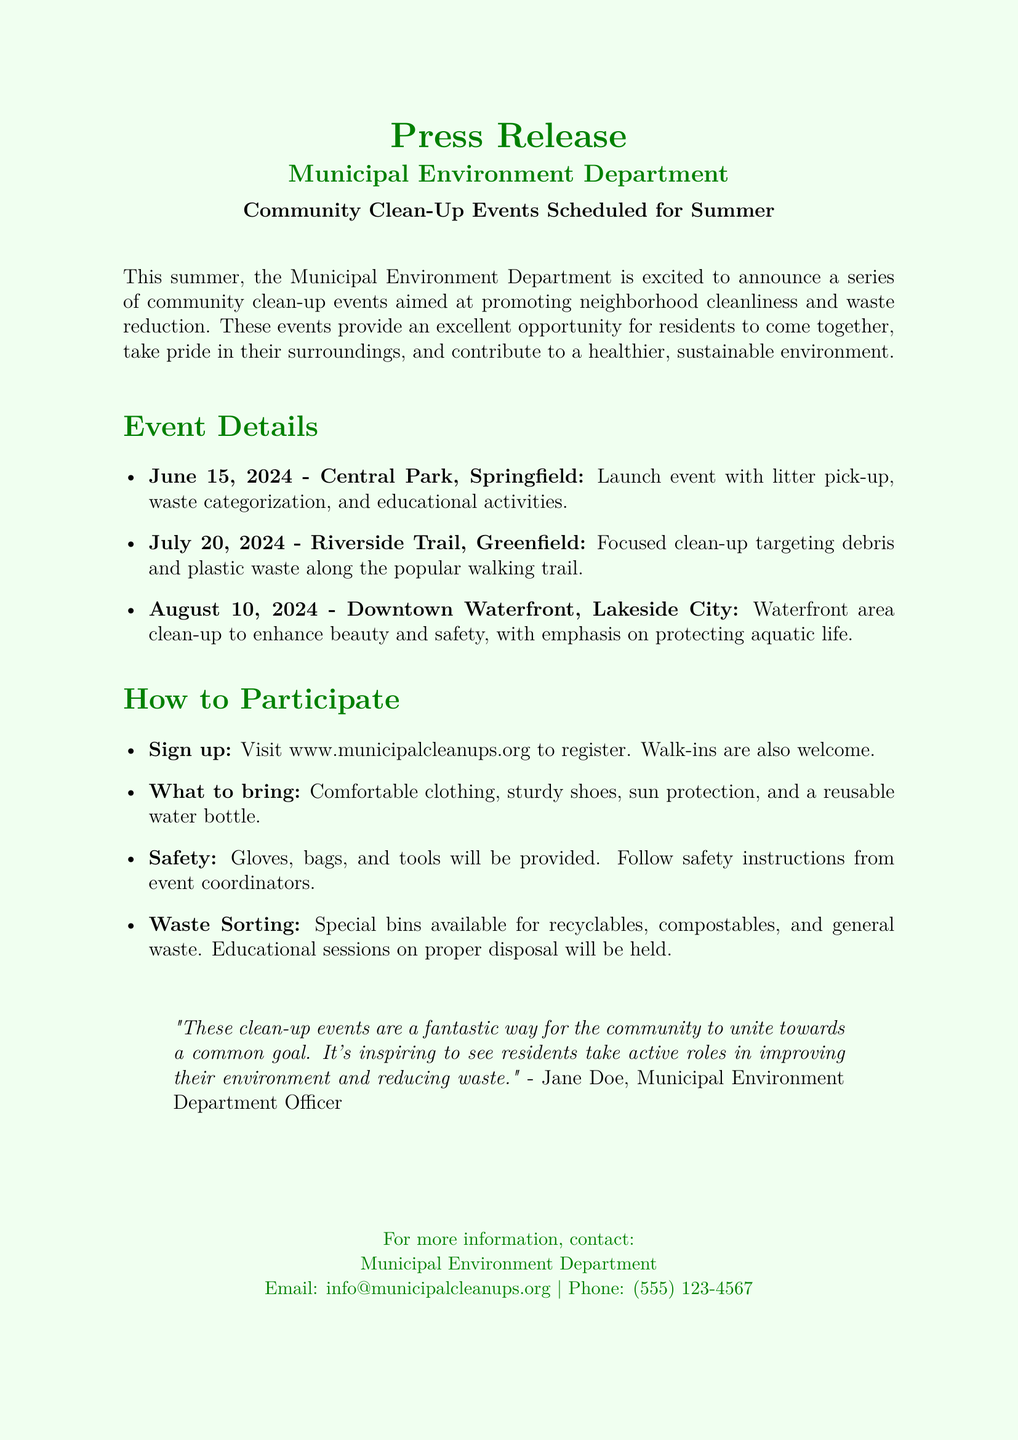What is the date of the launch event? The launch event is scheduled for June 15, 2024, at Central Park, Springfield.
Answer: June 15, 2024 What are residents encouraged to bring to the events? Residents are encouraged to bring comfortable clothing, sturdy shoes, sun protection, and a reusable water bottle.
Answer: Comfortable clothing, sturdy shoes, sun protection, and a reusable water bottle Which location is designated for the clean-up on July 20, 2024? The clean-up on July 20, 2024, will take place at Riverside Trail, Greenfield.
Answer: Riverside Trail, Greenfield What type of waste will be specifically targeted at the Riverside Trail event? The Riverside Trail event will specifically target debris and plastic waste.
Answer: Debris and plastic waste Who is the Municipal Environment Department Officer quoted in the press release? The quoted officer is Jane Doe from the Municipal Environment Department.
Answer: Jane Doe What will be provided at the events for safety? Safety gloves, bags, and tools will be provided at the events.
Answer: Gloves, bags, and tools What is the main goal of the community clean-up events? The main goal is to promote neighborhood cleanliness and waste reduction.
Answer: Promote neighborhood cleanliness and waste reduction How can residents sign up for the events? Residents can sign up by visiting www.municipalcleanups.org.
Answer: www.municipalcleanups.org What is the purpose of the special bins at the events? The special bins are for recyclable, compostable, and general waste.
Answer: Recyclable, compostable, and general waste 